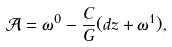<formula> <loc_0><loc_0><loc_500><loc_500>\mathcal { A } = \omega ^ { 0 } - \frac { C } { G } ( d z + \omega ^ { 1 } ) ,</formula> 